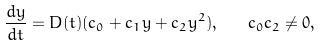Convert formula to latex. <formula><loc_0><loc_0><loc_500><loc_500>\frac { d y } { d t } = D ( t ) ( c _ { 0 } + c _ { 1 } y + c _ { 2 } y ^ { 2 } ) , \quad c _ { 0 } c _ { 2 } \neq 0 ,</formula> 